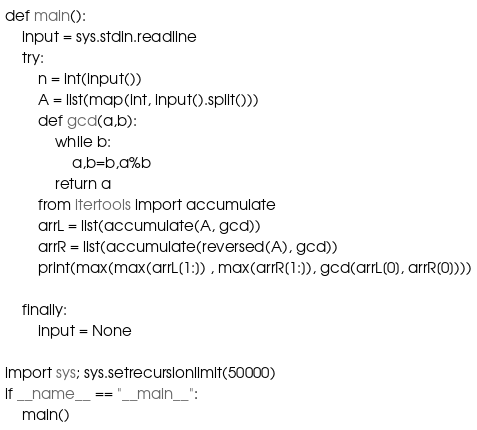<code> <loc_0><loc_0><loc_500><loc_500><_Python_>def main():
    input = sys.stdin.readline
    try:
        n = int(input())
        A = list(map(int, input().split()))
        def gcd(a,b):
            while b:
                a,b=b,a%b
            return a
        from itertools import accumulate
        arrL = list(accumulate(A, gcd))
        arrR = list(accumulate(reversed(A), gcd))
        print(max(max(arrL[1:]) , max(arrR[1:]), gcd(arrL[0], arrR[0])))
        
    finally:
        input = None

import sys; sys.setrecursionlimit(50000)
if __name__ == "__main__":
    main()
</code> 